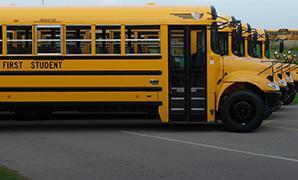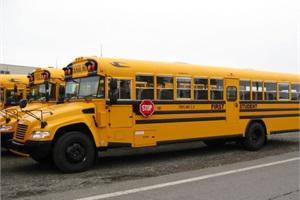The first image is the image on the left, the second image is the image on the right. Considering the images on both sides, is "Buses are lined up side by side in at least one of the images." valid? Answer yes or no. Yes. The first image is the image on the left, the second image is the image on the right. Assess this claim about the two images: "A short school bus with no more than four windows in the body side has standard wide turning mirrors at the front of the hood.". Correct or not? Answer yes or no. No. 